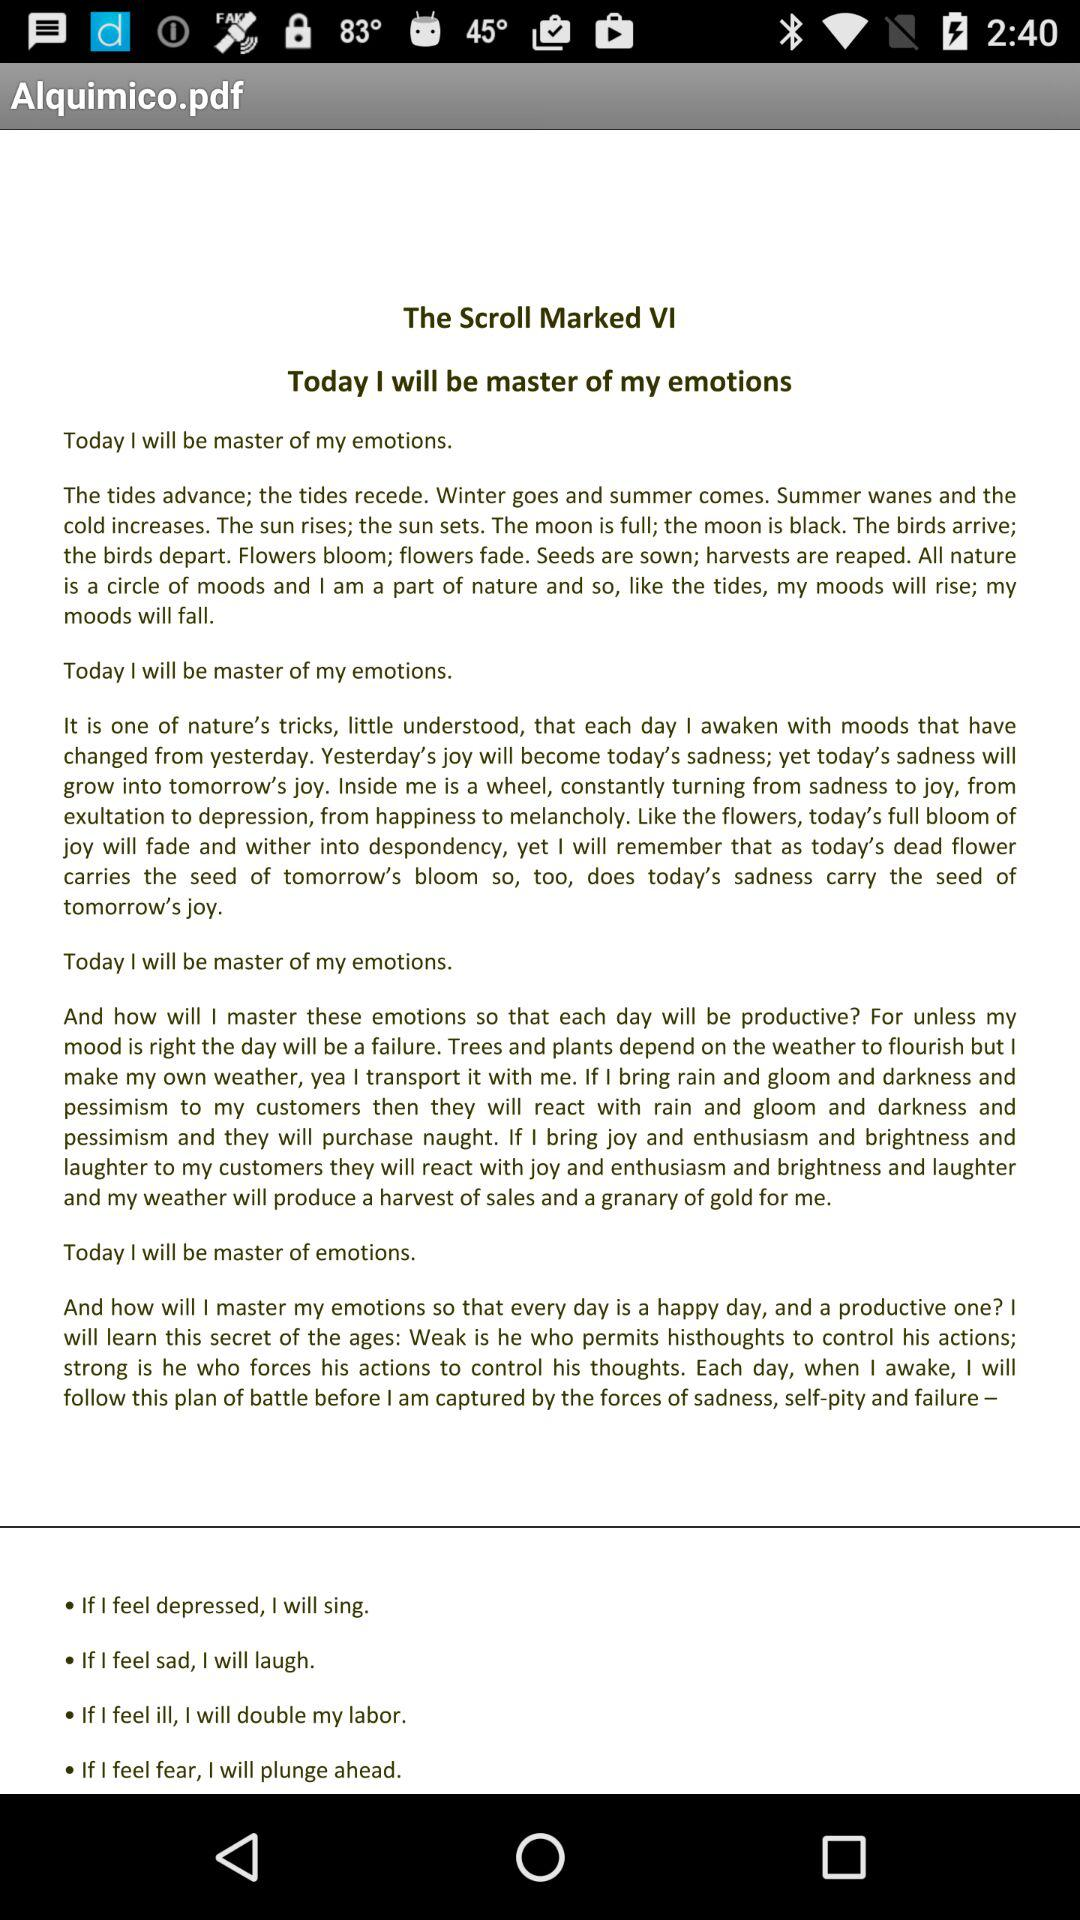How many instructions are provided to help the reader control their emotions?
Answer the question using a single word or phrase. 4 